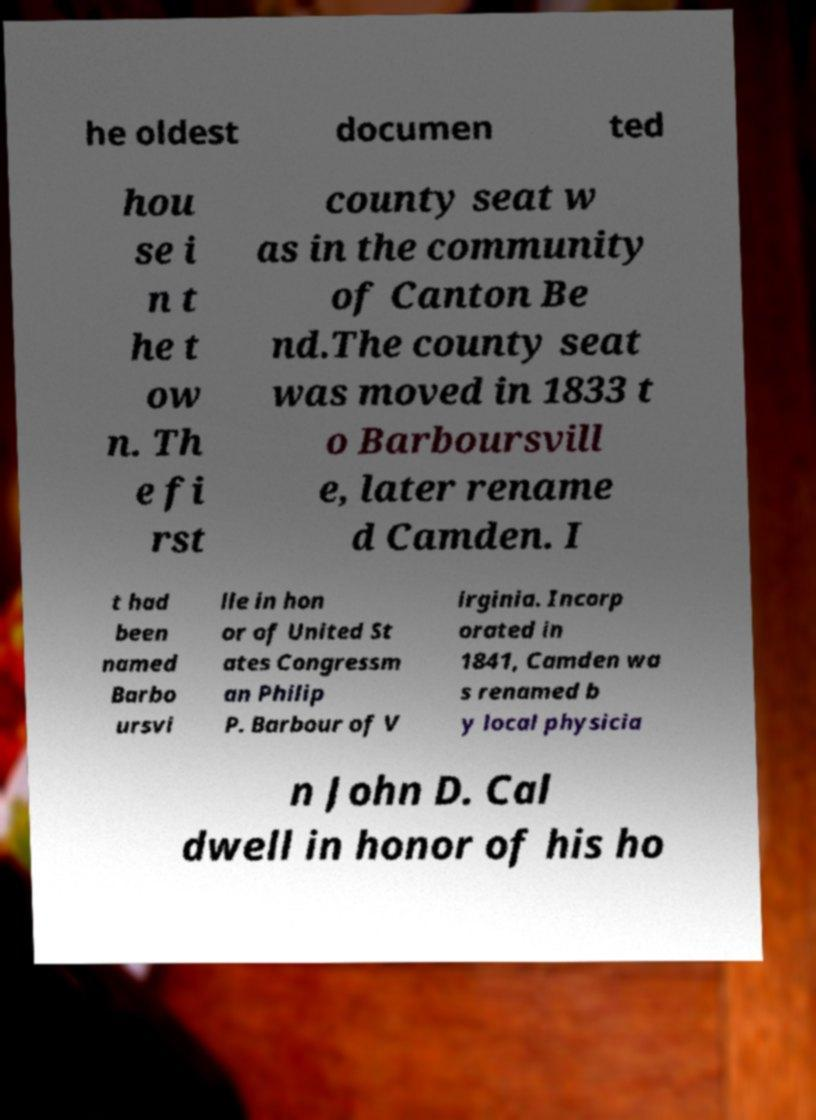Please read and relay the text visible in this image. What does it say? he oldest documen ted hou se i n t he t ow n. Th e fi rst county seat w as in the community of Canton Be nd.The county seat was moved in 1833 t o Barboursvill e, later rename d Camden. I t had been named Barbo ursvi lle in hon or of United St ates Congressm an Philip P. Barbour of V irginia. Incorp orated in 1841, Camden wa s renamed b y local physicia n John D. Cal dwell in honor of his ho 